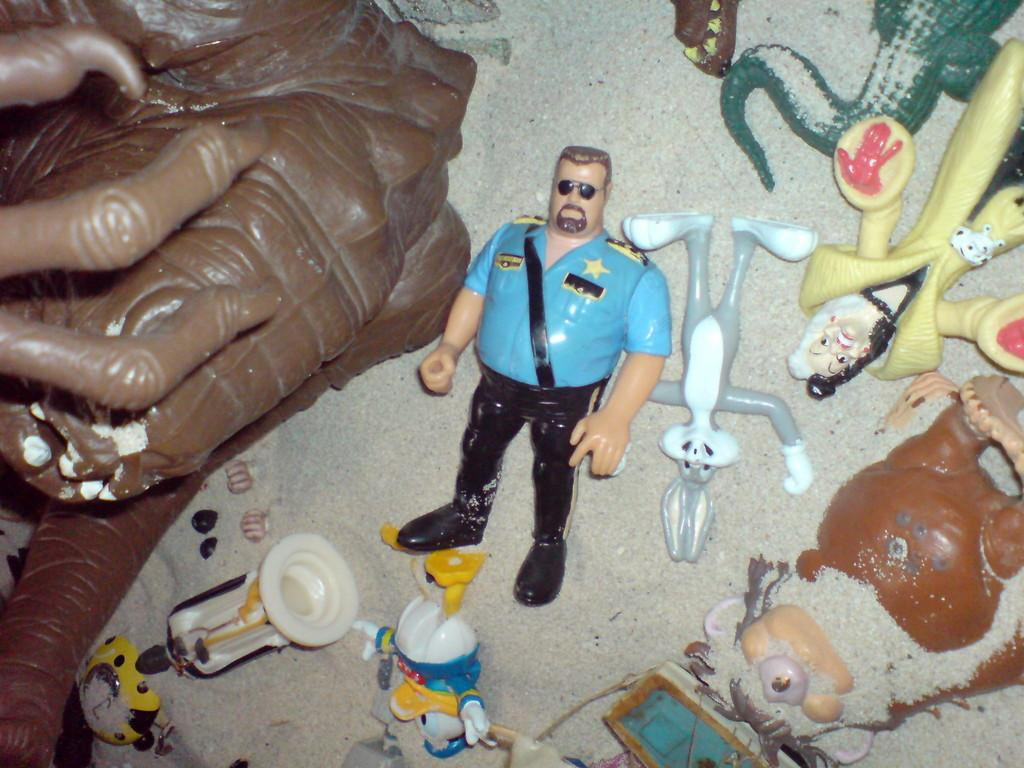What type of objects can be seen in the image? There are many toys in the image. Can you describe the toys in more detail? Unfortunately, without additional information, it is difficult to provide more specific details about the toys. What type of ink is being used to color the sack in the image? There is no sack or ink present in the image; it only features many toys. 